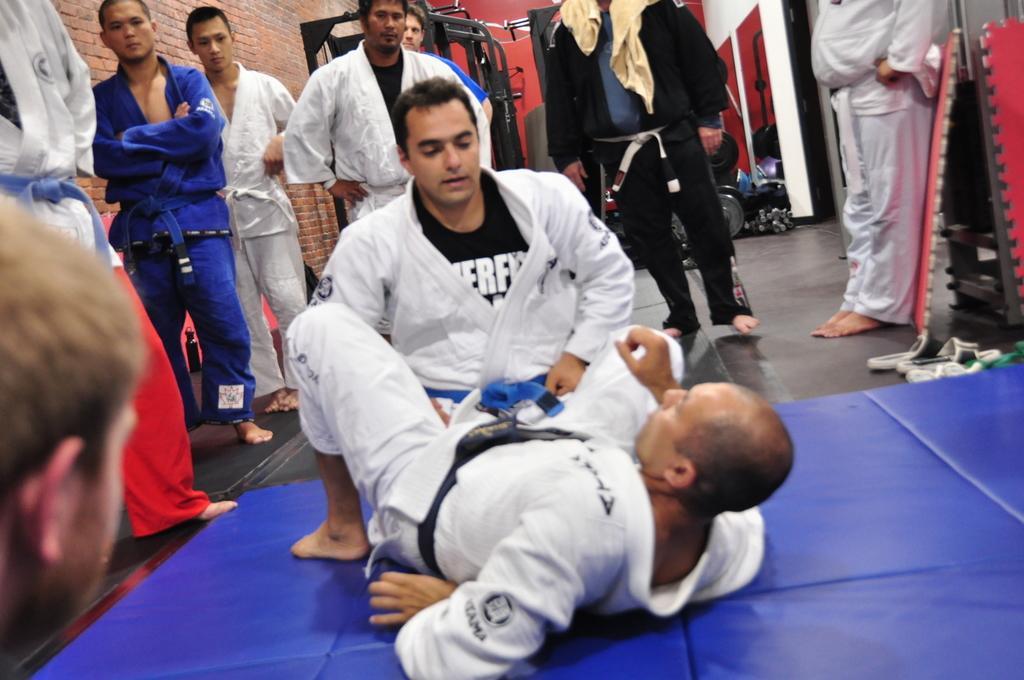Describe this image in one or two sentences. Two men are performing karate and around them a group of people are standing by wearing the karate costume,behind the people there is some equipment. 